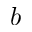Convert formula to latex. <formula><loc_0><loc_0><loc_500><loc_500>b</formula> 